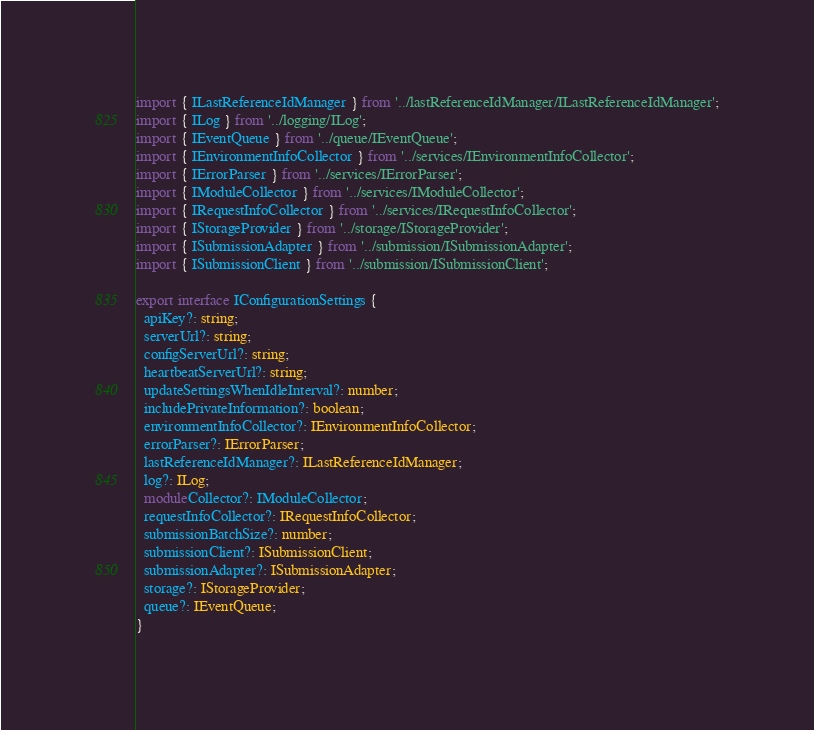<code> <loc_0><loc_0><loc_500><loc_500><_TypeScript_>import { ILastReferenceIdManager } from '../lastReferenceIdManager/ILastReferenceIdManager';
import { ILog } from '../logging/ILog';
import { IEventQueue } from '../queue/IEventQueue';
import { IEnvironmentInfoCollector } from '../services/IEnvironmentInfoCollector';
import { IErrorParser } from '../services/IErrorParser';
import { IModuleCollector } from '../services/IModuleCollector';
import { IRequestInfoCollector } from '../services/IRequestInfoCollector';
import { IStorageProvider } from '../storage/IStorageProvider';
import { ISubmissionAdapter } from '../submission/ISubmissionAdapter';
import { ISubmissionClient } from '../submission/ISubmissionClient';

export interface IConfigurationSettings {
  apiKey?: string;
  serverUrl?: string;
  configServerUrl?: string;
  heartbeatServerUrl?: string;
  updateSettingsWhenIdleInterval?: number;
  includePrivateInformation?: boolean;
  environmentInfoCollector?: IEnvironmentInfoCollector;
  errorParser?: IErrorParser;
  lastReferenceIdManager?: ILastReferenceIdManager;
  log?: ILog;
  moduleCollector?: IModuleCollector;
  requestInfoCollector?: IRequestInfoCollector;
  submissionBatchSize?: number;
  submissionClient?: ISubmissionClient;
  submissionAdapter?: ISubmissionAdapter;
  storage?: IStorageProvider;
  queue?: IEventQueue;
}
</code> 